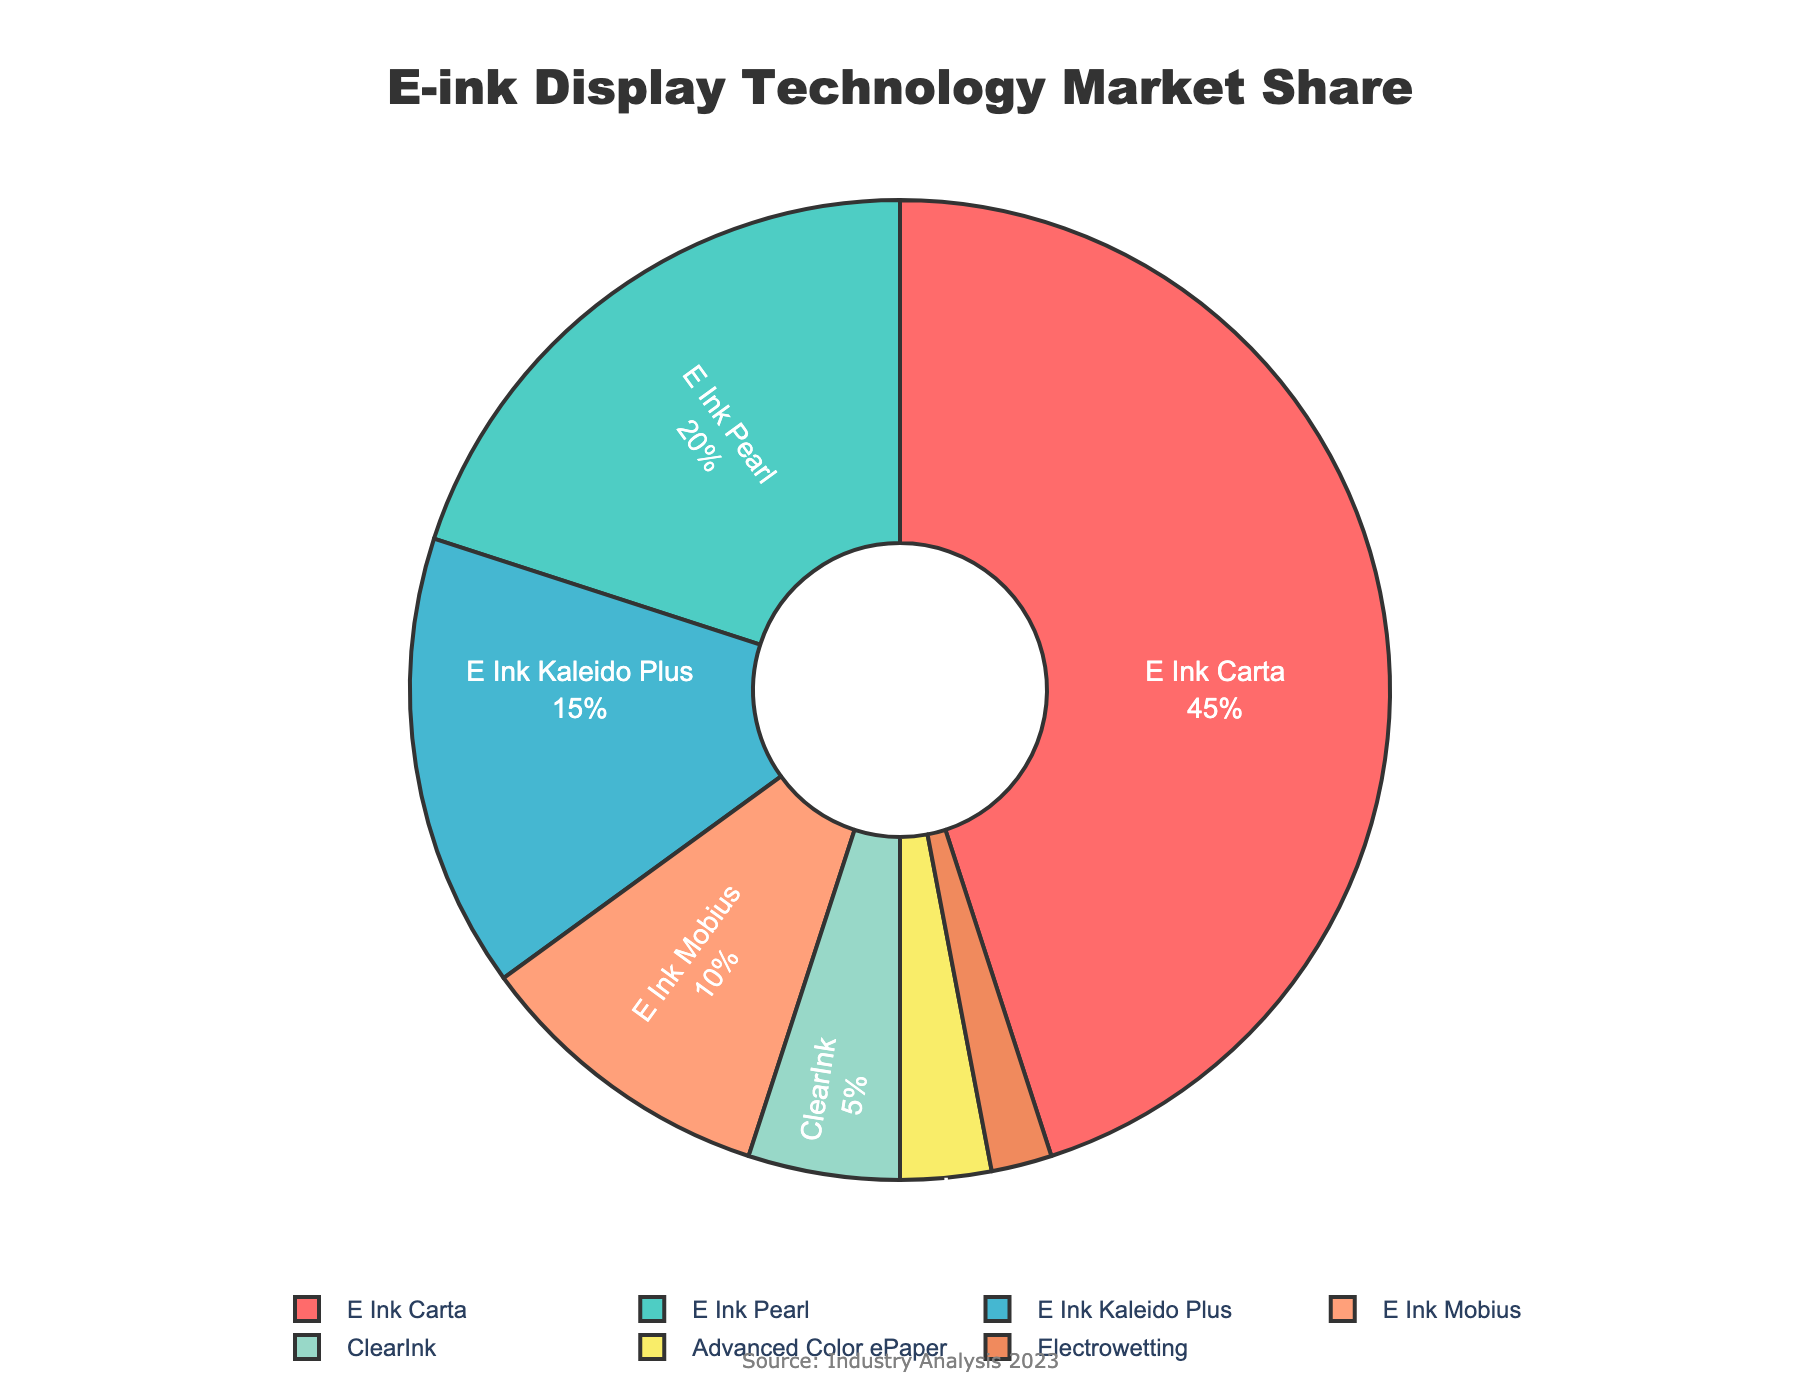What's the most common E-ink display technology type? The pie chart shows that "E Ink Carta" occupies the largest portion of the pie with 45% market share, which is the highest compared to other types.
Answer: E Ink Carta What's the least common E-ink display technology type? The pie chart indicates that "Electrowetting" has the smallest segment, occupying only 2% of the market share.
Answer: Electrowetting Which display technologies together have a market share greater than 50%? Adding the market shares of "E Ink Carta" (45%), "E Ink Pearl" (20%), and "E Ink Kaleido Plus" (15%) results in 80%, which is greater than 50%.
Answer: E Ink Carta, E Ink Pearl, E Ink Kaleido Plus How much larger is the market share of E Ink Carta compared to ClearInk? The market share of E Ink Carta is 45%, and ClearInk is 5%. The difference is calculated as 45% - 5% = 40%.
Answer: 40% What's the total market share of Advanced Color ePaper and Electrowetting combined? The market share of Advanced Color ePaper is 3%, and Electrowetting is 2%. Adding these together, 3% + 2% = 5%.
Answer: 5% How does the market share of E Ink Kaleido Plus compare to that of E Ink Mobius? E Ink Kaleido Plus has a market share of 15%, while E Ink Mobius has a market share of 10%. E Ink Kaleido Plus has 5% more than E Ink Mobius.
Answer: 5% more What is the combined market share of E Ink technologies (excluding non-E Ink)? Summing up the market shares of E Ink Carta (45%), E Ink Pearl (20%), E Ink Kaleido Plus (15%), and E Ink Mobius (10%) gives 45% + 20% + 15% + 10% = 90%.
Answer: 90% What percentage of the market is made up by non-E Ink display technologies? Adding the market shares of ClearInk (5%), Advanced Color ePaper (3%), and Electrowetting (2%) results in 5% + 3% + 2% = 10%.
Answer: 10% Which display technology is represented by the blue color in the chart? By observing the color coding in the chart, the blue segment corresponds to "E Ink Kaleido Plus" with a market share of 15%.
Answer: E Ink Kaleido Plus If the total market share were to be evenly distributed among four display technologies, what would be the required market share for each? An even distribution among four technologies would mean dividing 100% by 4. So, 100% / 4 = 25%.
Answer: 25% 